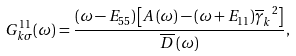<formula> <loc_0><loc_0><loc_500><loc_500>G _ { k \sigma } ^ { 1 1 } ( \omega ) = \frac { ( \omega - E _ { 5 5 } ) \left [ A \left ( \omega \right ) - ( \omega + E _ { 1 1 } ) { \overline { \gamma } _ { k } } ^ { 2 } \right ] } { \overline { D } \left ( \omega \right ) } ,</formula> 